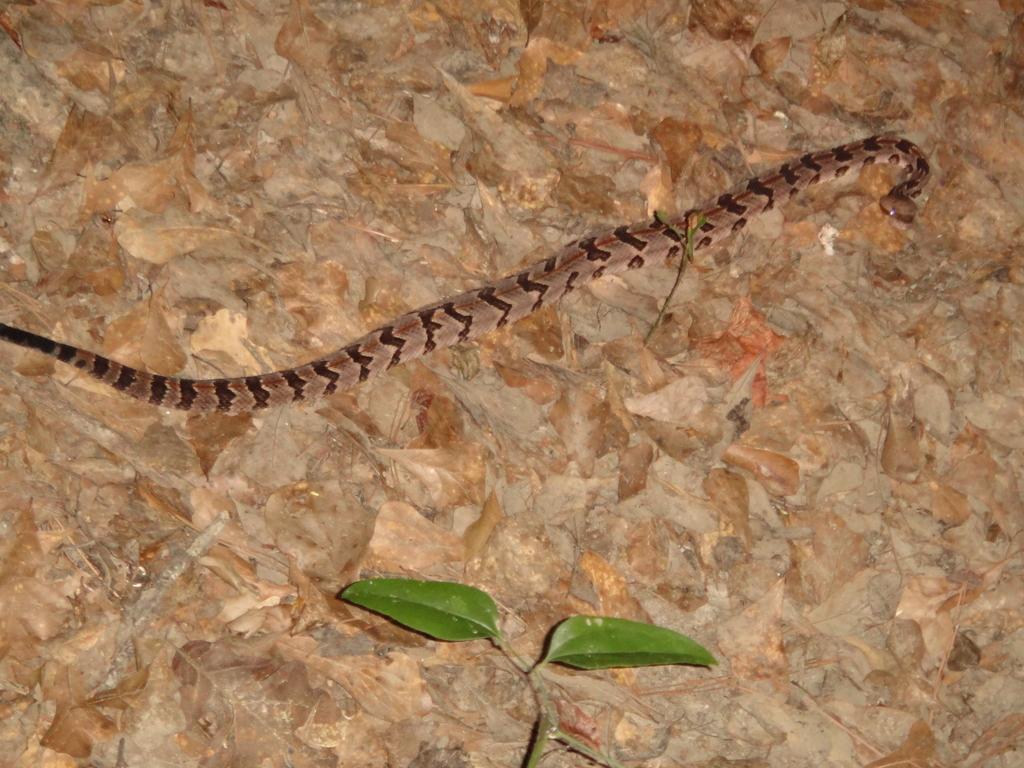Could you give a brief overview of what you see in this image? In this image, we can see a snake and we can see two green leaves. 